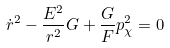Convert formula to latex. <formula><loc_0><loc_0><loc_500><loc_500>\dot { r } ^ { 2 } - \frac { E ^ { 2 } } { r ^ { 2 } } G + \frac { G } { F } p _ { \chi } ^ { 2 } = 0</formula> 